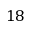Convert formula to latex. <formula><loc_0><loc_0><loc_500><loc_500>1 8</formula> 